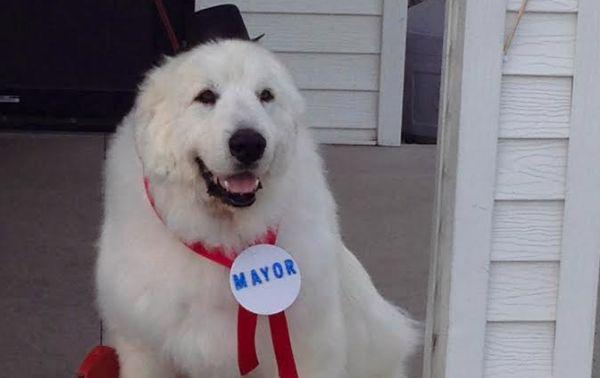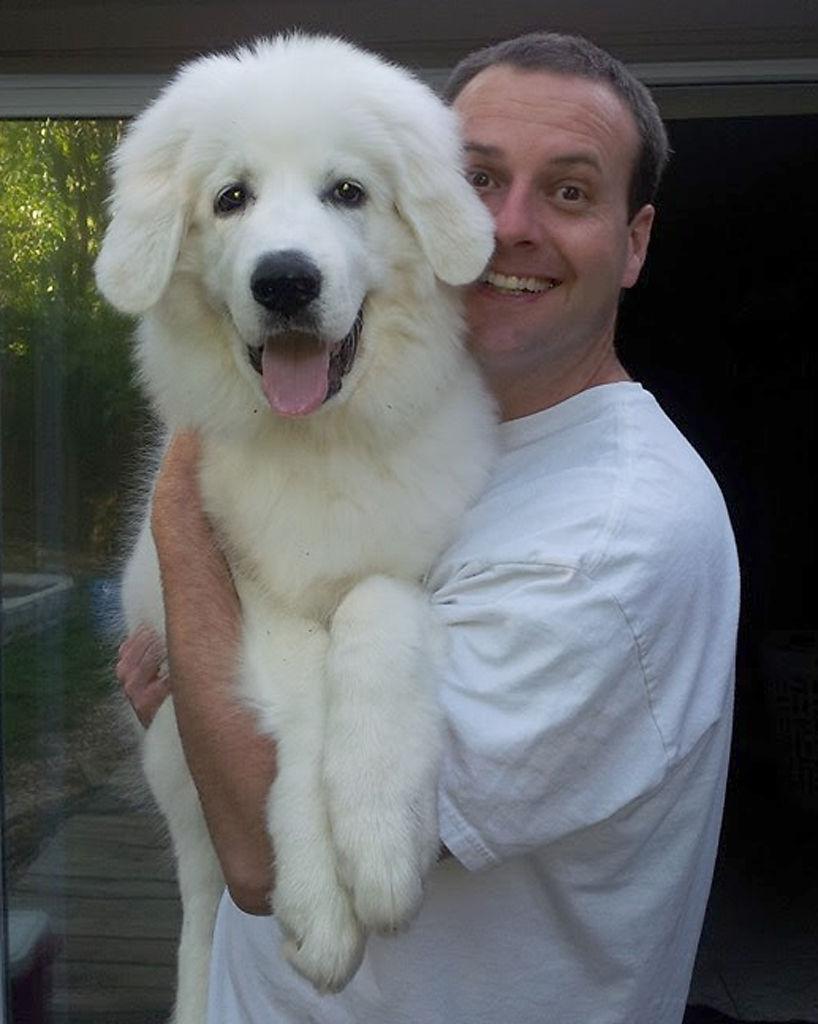The first image is the image on the left, the second image is the image on the right. For the images displayed, is the sentence "There is a human holding a dog in the image on the right." factually correct? Answer yes or no. Yes. The first image is the image on the left, the second image is the image on the right. Considering the images on both sides, is "A man is standing while holding a big white dog." valid? Answer yes or no. Yes. 